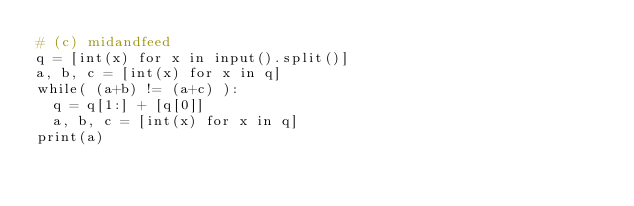Convert code to text. <code><loc_0><loc_0><loc_500><loc_500><_Python_># (c) midandfeed
q = [int(x) for x in input().split()]
a, b, c = [int(x) for x in q]
while( (a+b) != (a+c) ):
	q = q[1:] + [q[0]]
	a, b, c = [int(x) for x in q]
print(a)</code> 